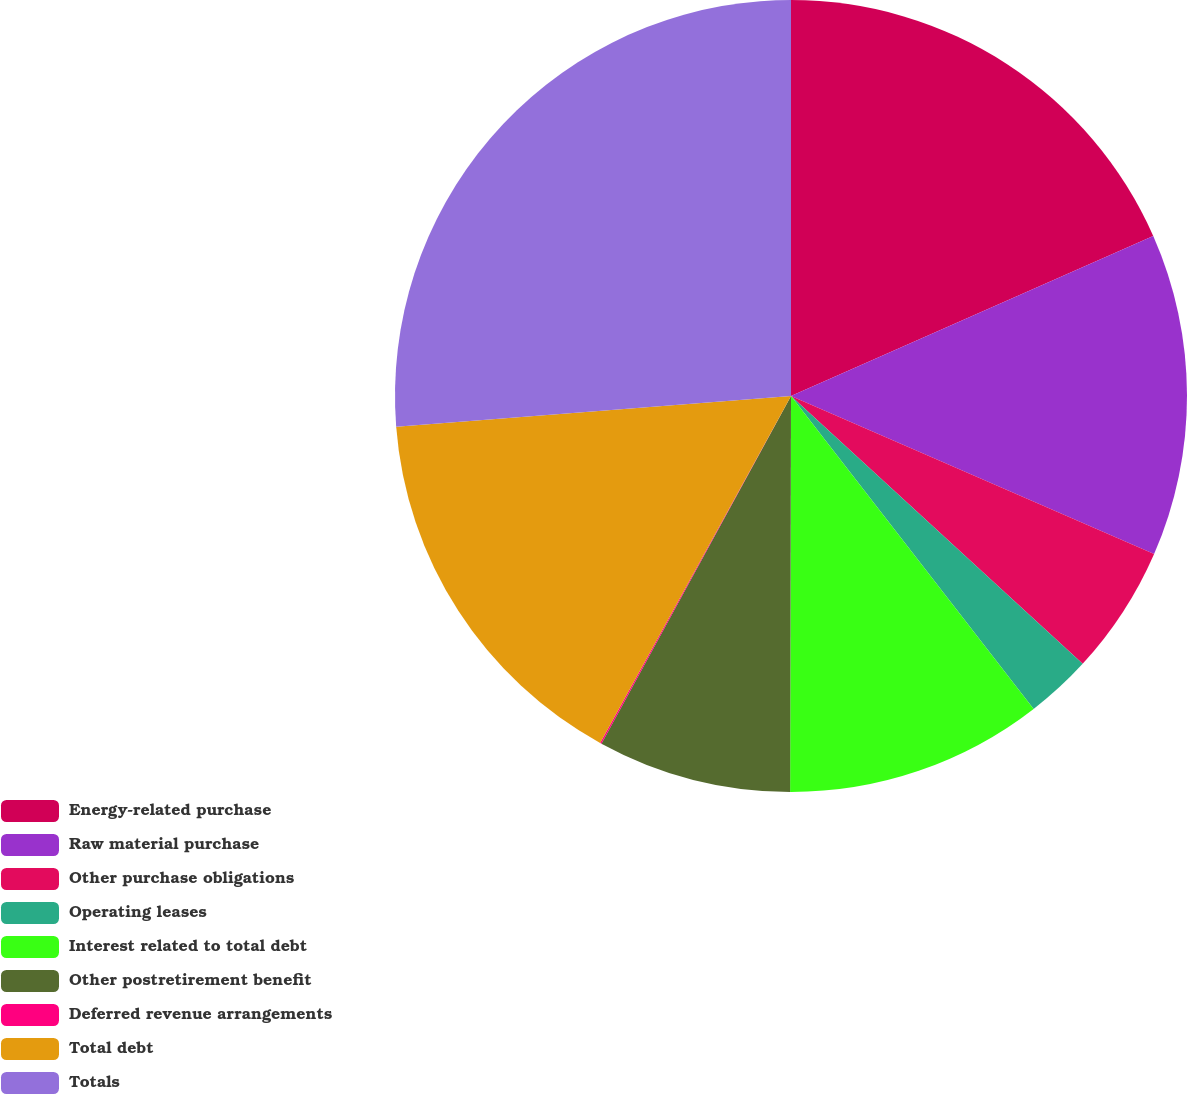Convert chart. <chart><loc_0><loc_0><loc_500><loc_500><pie_chart><fcel>Energy-related purchase<fcel>Raw material purchase<fcel>Other purchase obligations<fcel>Operating leases<fcel>Interest related to total debt<fcel>Other postretirement benefit<fcel>Deferred revenue arrangements<fcel>Total debt<fcel>Totals<nl><fcel>18.38%<fcel>13.15%<fcel>5.29%<fcel>2.68%<fcel>10.53%<fcel>7.91%<fcel>0.06%<fcel>15.76%<fcel>26.23%<nl></chart> 